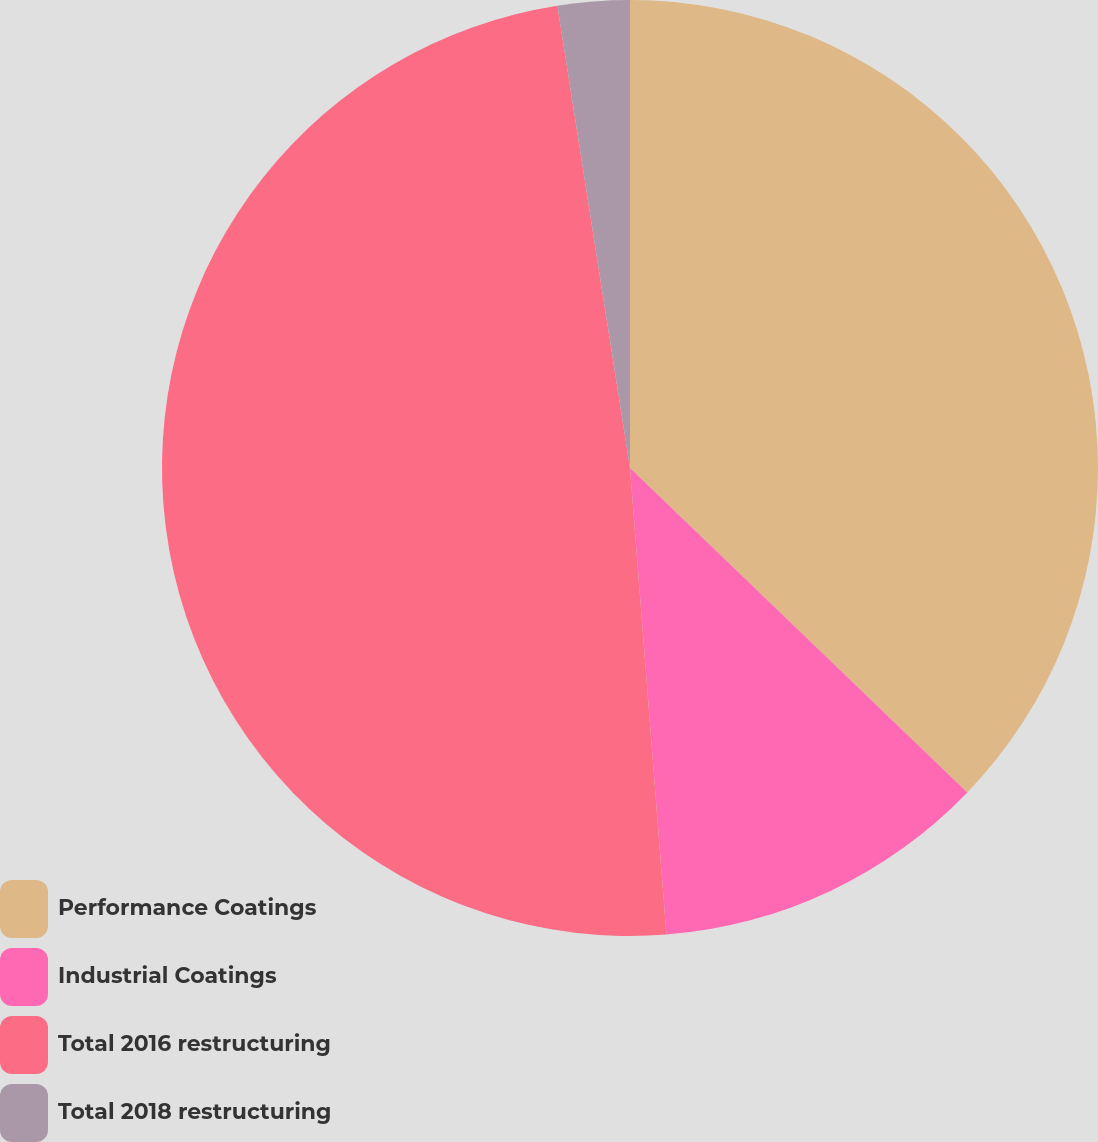Convert chart. <chart><loc_0><loc_0><loc_500><loc_500><pie_chart><fcel>Performance Coatings<fcel>Industrial Coatings<fcel>Total 2016 restructuring<fcel>Total 2018 restructuring<nl><fcel>37.19%<fcel>11.57%<fcel>48.76%<fcel>2.48%<nl></chart> 